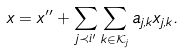Convert formula to latex. <formula><loc_0><loc_0><loc_500><loc_500>x = x ^ { \prime \prime } + \sum _ { j \prec i ^ { \prime } } \sum _ { k \in { \mathcal { K } } _ { j } } a _ { j , k } x _ { j , k } .</formula> 